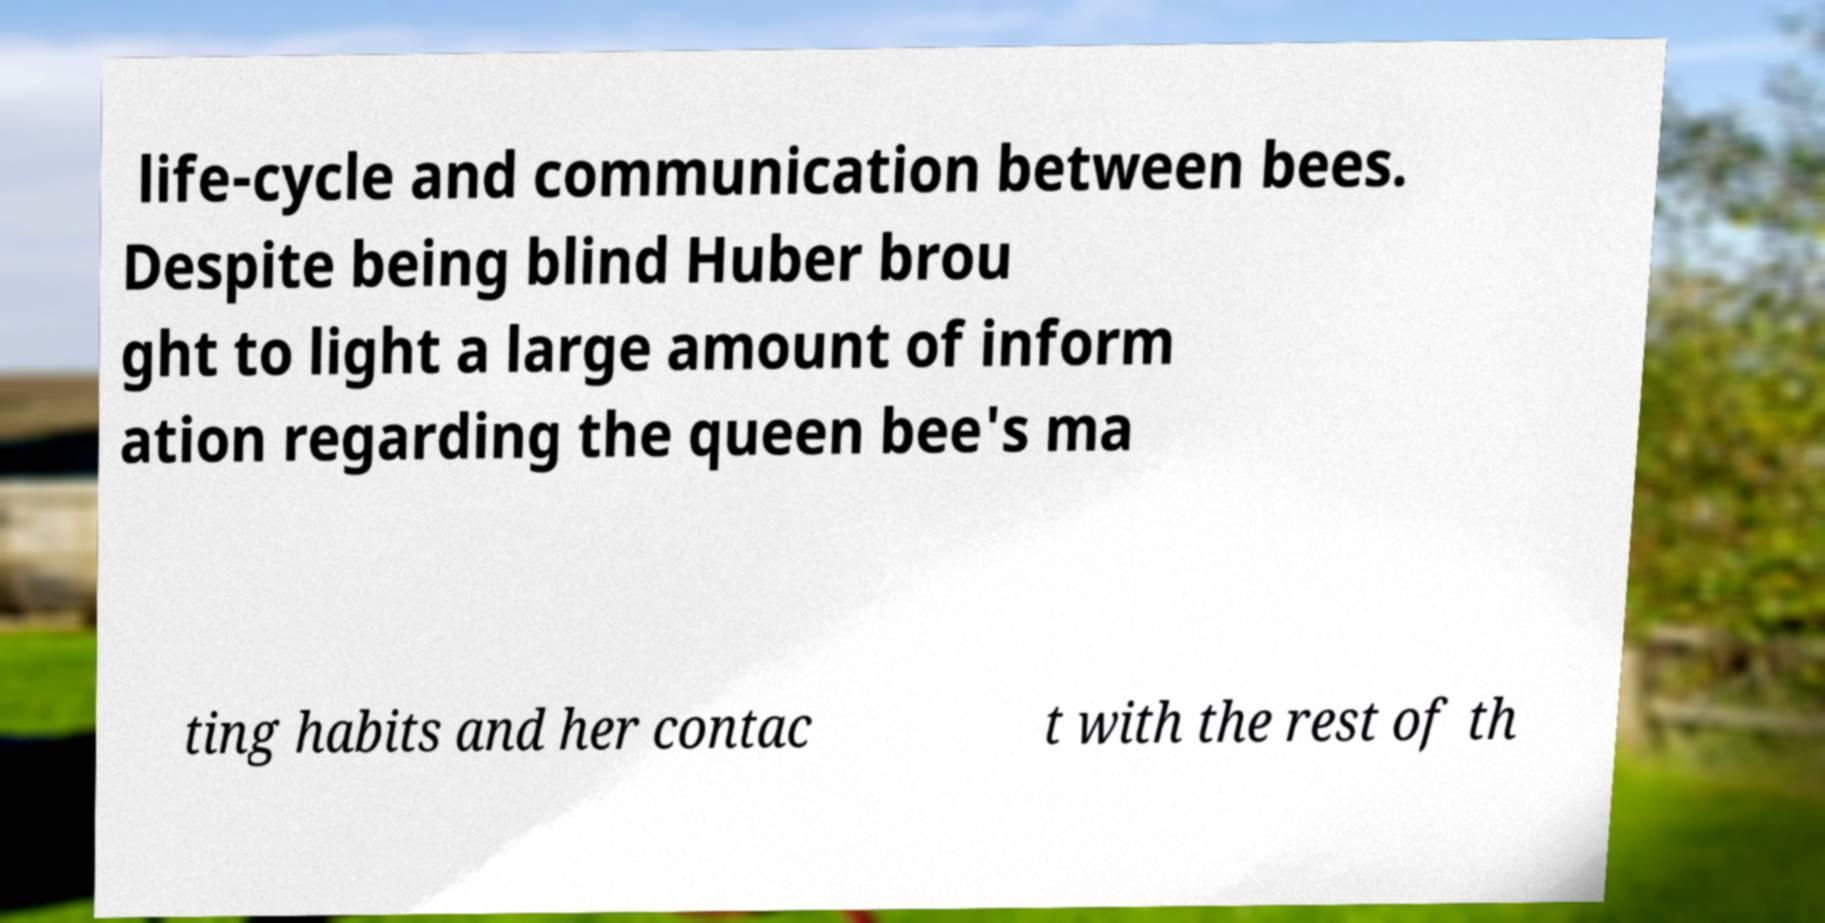For documentation purposes, I need the text within this image transcribed. Could you provide that? life-cycle and communication between bees. Despite being blind Huber brou ght to light a large amount of inform ation regarding the queen bee's ma ting habits and her contac t with the rest of th 